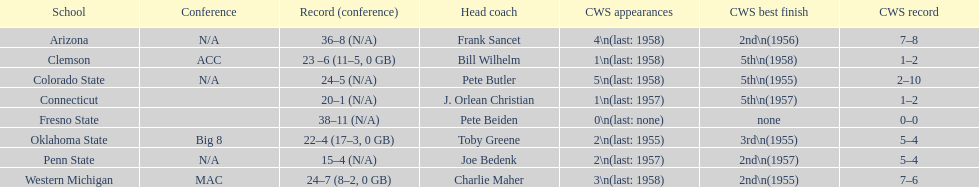What are the squads in the conference? Arizona, Clemson, Colorado State, Connecticut, Fresno State, Oklahoma State, Penn State, Western Michigan. Which have more than 16 triumphs? Arizona, Clemson, Colorado State, Connecticut, Fresno State, Oklahoma State, Western Michigan. Which had under 16 triumphs? Penn State. 